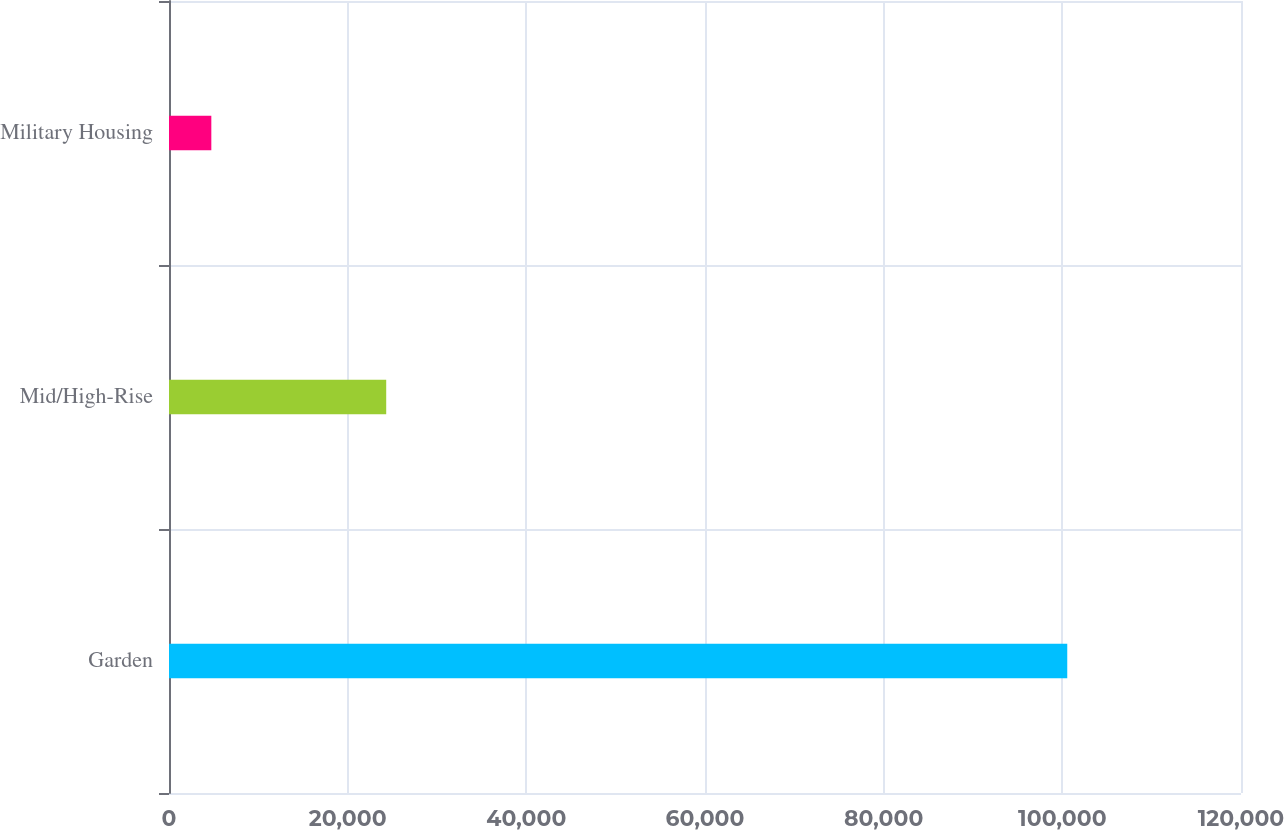Convert chart. <chart><loc_0><loc_0><loc_500><loc_500><bar_chart><fcel>Garden<fcel>Mid/High-Rise<fcel>Military Housing<nl><fcel>100551<fcel>24315<fcel>4738<nl></chart> 